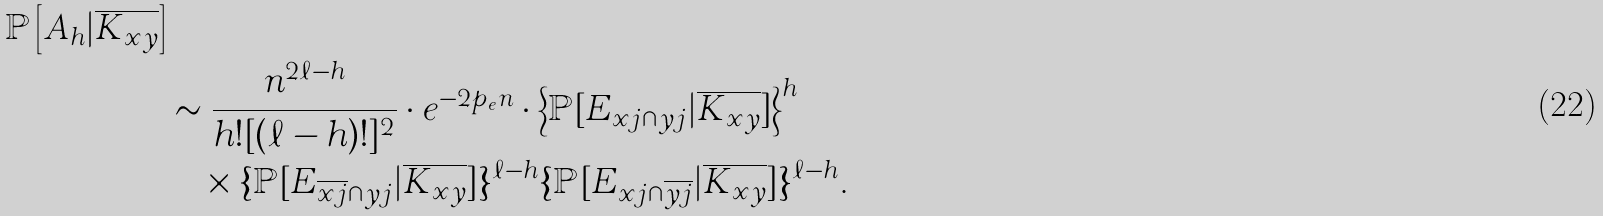<formula> <loc_0><loc_0><loc_500><loc_500>{ \mathbb { P } \left [ A _ { h } | \overline { K _ { { x } { y } } } \right ] } \\ & \sim \frac { n ^ { 2 \ell - h } } { h ! [ ( \ell - h ) ! ] ^ { 2 } } \cdot e ^ { - 2 { p _ { e } } n } \cdot \left \{ \mathbb { P } [ E _ { { x } j \cap { y } j } | \overline { K _ { { x } { y } } } ] \right \} ^ { h } \\ & \quad \times \{ \mathbb { P } [ E _ { \overline { { x } j } \cap { y } j } | \overline { K _ { { x } { y } } } ] \} ^ { { \ell } - h } \{ \mathbb { P } [ E _ { { x } j \cap { \overline { y j } } } | \overline { K _ { { x } { y } } } ] \} ^ { { \ell } - h } .</formula> 